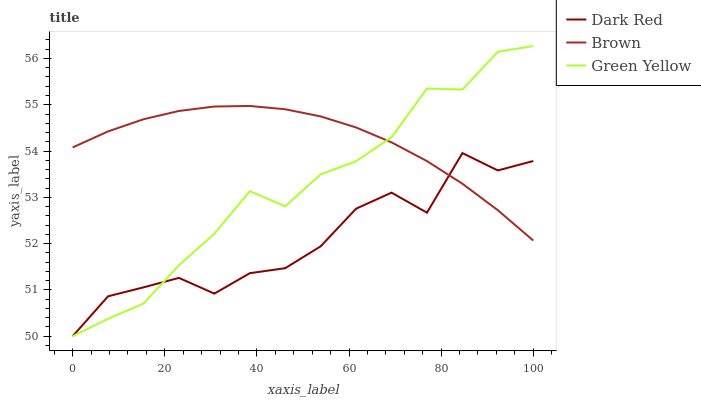Does Green Yellow have the minimum area under the curve?
Answer yes or no. No. Does Green Yellow have the maximum area under the curve?
Answer yes or no. No. Is Green Yellow the smoothest?
Answer yes or no. No. Is Green Yellow the roughest?
Answer yes or no. No. Does Brown have the lowest value?
Answer yes or no. No. Does Brown have the highest value?
Answer yes or no. No. 